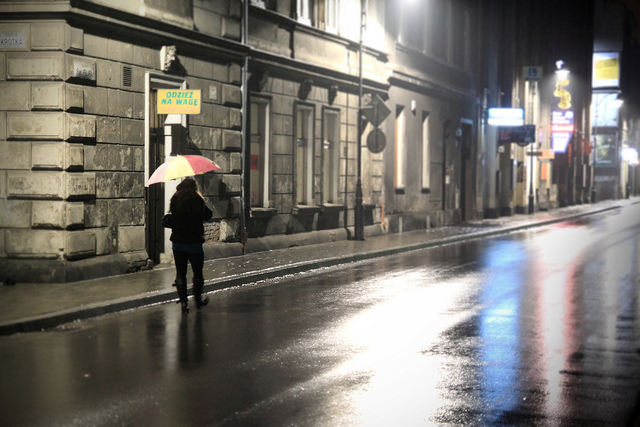Identify the text displayed in this image. WAGE 